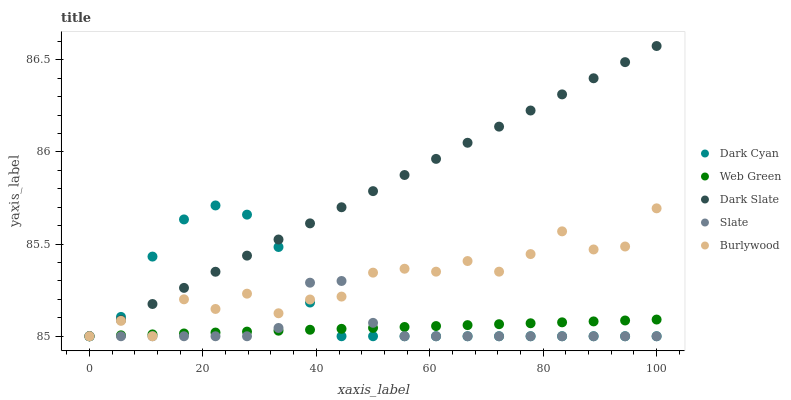Does Slate have the minimum area under the curve?
Answer yes or no. Yes. Does Dark Slate have the maximum area under the curve?
Answer yes or no. Yes. Does Dark Slate have the minimum area under the curve?
Answer yes or no. No. Does Slate have the maximum area under the curve?
Answer yes or no. No. Is Web Green the smoothest?
Answer yes or no. Yes. Is Burlywood the roughest?
Answer yes or no. Yes. Is Dark Slate the smoothest?
Answer yes or no. No. Is Dark Slate the roughest?
Answer yes or no. No. Does Dark Cyan have the lowest value?
Answer yes or no. Yes. Does Dark Slate have the highest value?
Answer yes or no. Yes. Does Slate have the highest value?
Answer yes or no. No. Does Slate intersect Dark Slate?
Answer yes or no. Yes. Is Slate less than Dark Slate?
Answer yes or no. No. Is Slate greater than Dark Slate?
Answer yes or no. No. 